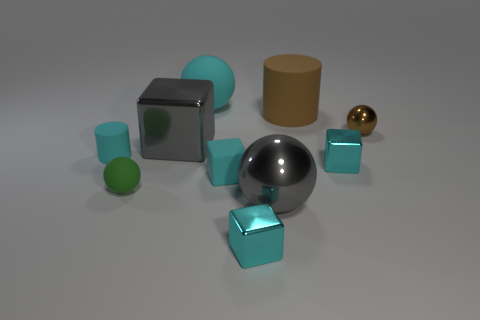The large thing that is on the left side of the big cylinder and behind the tiny brown ball has what shape?
Your answer should be compact. Sphere. How many other objects are the same color as the small cylinder?
Provide a succinct answer. 4. What number of things are either cyan rubber objects that are behind the tiny brown object or cyan matte spheres?
Make the answer very short. 1. There is a small matte block; does it have the same color as the cylinder that is behind the tiny metal ball?
Make the answer very short. No. Is there anything else that is the same size as the gray shiny sphere?
Your response must be concise. Yes. How big is the gray metal thing left of the cyan object behind the small cyan cylinder?
Offer a very short reply. Large. What number of things are either small purple rubber cylinders or rubber things that are to the right of the big shiny sphere?
Provide a succinct answer. 1. There is a gray metal object behind the green matte ball; is its shape the same as the brown matte thing?
Ensure brevity in your answer.  No. What number of small objects are on the right side of the tiny sphere in front of the tiny ball that is on the right side of the big gray sphere?
Your answer should be compact. 4. Are there any other things that are the same shape as the big brown thing?
Your answer should be compact. Yes. 